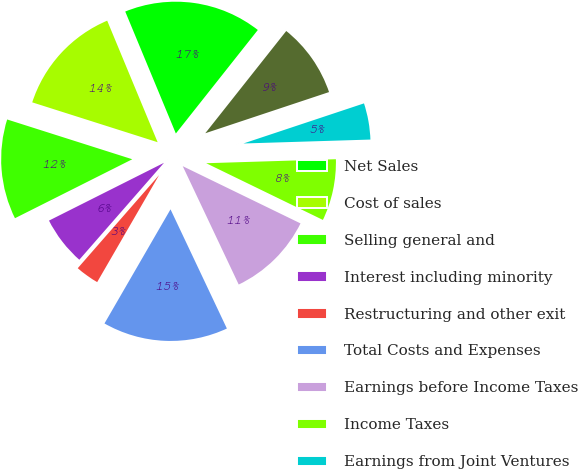Convert chart to OTSL. <chart><loc_0><loc_0><loc_500><loc_500><pie_chart><fcel>Net Sales<fcel>Cost of sales<fcel>Selling general and<fcel>Interest including minority<fcel>Restructuring and other exit<fcel>Total Costs and Expenses<fcel>Earnings before Income Taxes<fcel>Income Taxes<fcel>Earnings from Joint Ventures<fcel>Net Earnings<nl><fcel>16.92%<fcel>13.84%<fcel>12.31%<fcel>6.16%<fcel>3.08%<fcel>15.38%<fcel>10.77%<fcel>7.69%<fcel>4.62%<fcel>9.23%<nl></chart> 